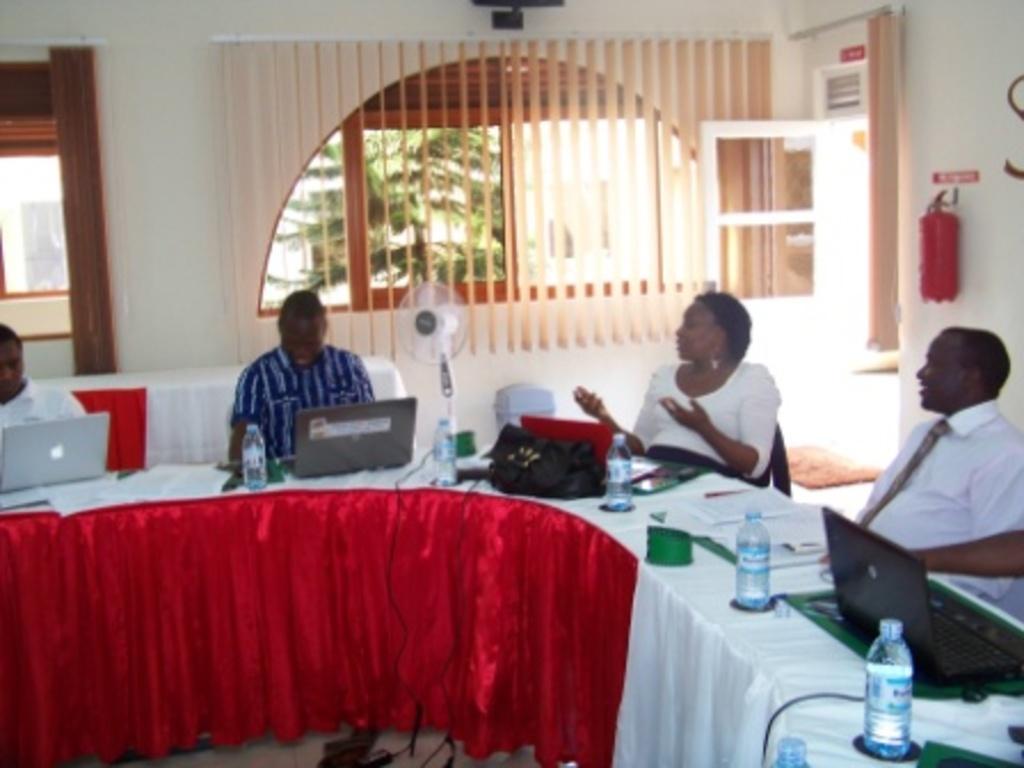Describe this image in one or two sentences. In this image there are group of people sitting behind the table. There are laptops, bottles, bags, wires, papers on the table. The table is covered with the red and white cloth. there is a fan and there is a window and at the left there is a door. outside the window there is a tree and at the right there is a fire extinguisher. 